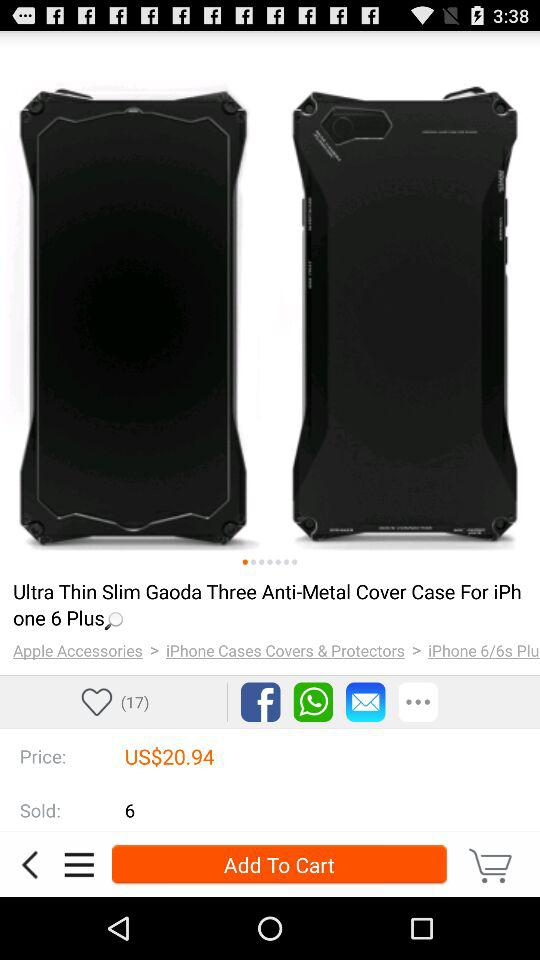What is the price of "Anti-Metal Cover"? The price is 20.94 USD. 